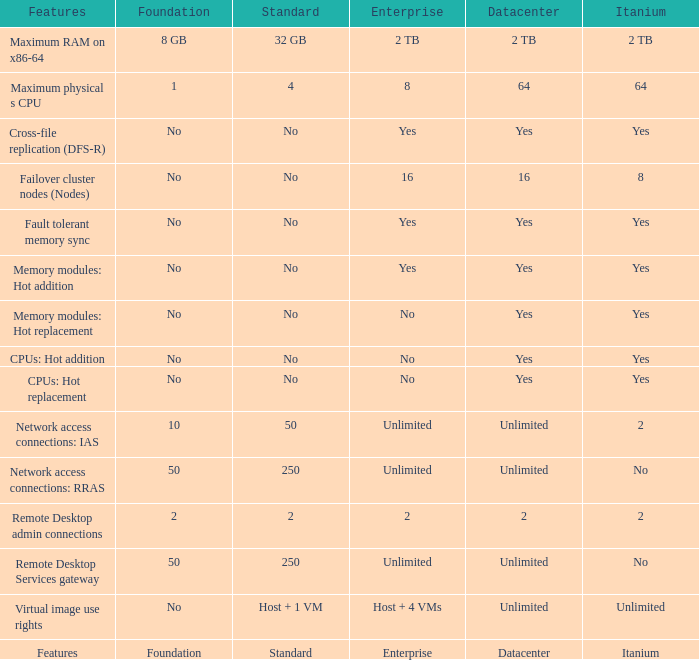What is the Enterprise for teh memory modules: hot replacement Feature that has a Datacenter of Yes? No. 